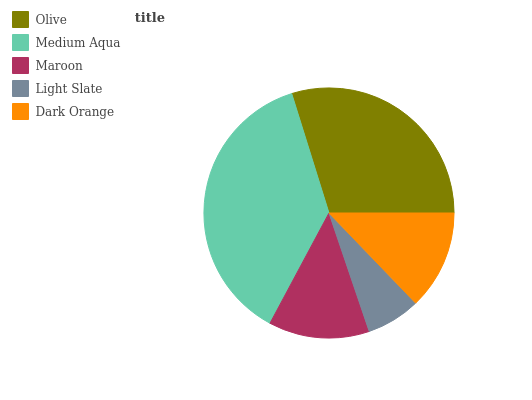Is Light Slate the minimum?
Answer yes or no. Yes. Is Medium Aqua the maximum?
Answer yes or no. Yes. Is Maroon the minimum?
Answer yes or no. No. Is Maroon the maximum?
Answer yes or no. No. Is Medium Aqua greater than Maroon?
Answer yes or no. Yes. Is Maroon less than Medium Aqua?
Answer yes or no. Yes. Is Maroon greater than Medium Aqua?
Answer yes or no. No. Is Medium Aqua less than Maroon?
Answer yes or no. No. Is Maroon the high median?
Answer yes or no. Yes. Is Maroon the low median?
Answer yes or no. Yes. Is Olive the high median?
Answer yes or no. No. Is Medium Aqua the low median?
Answer yes or no. No. 